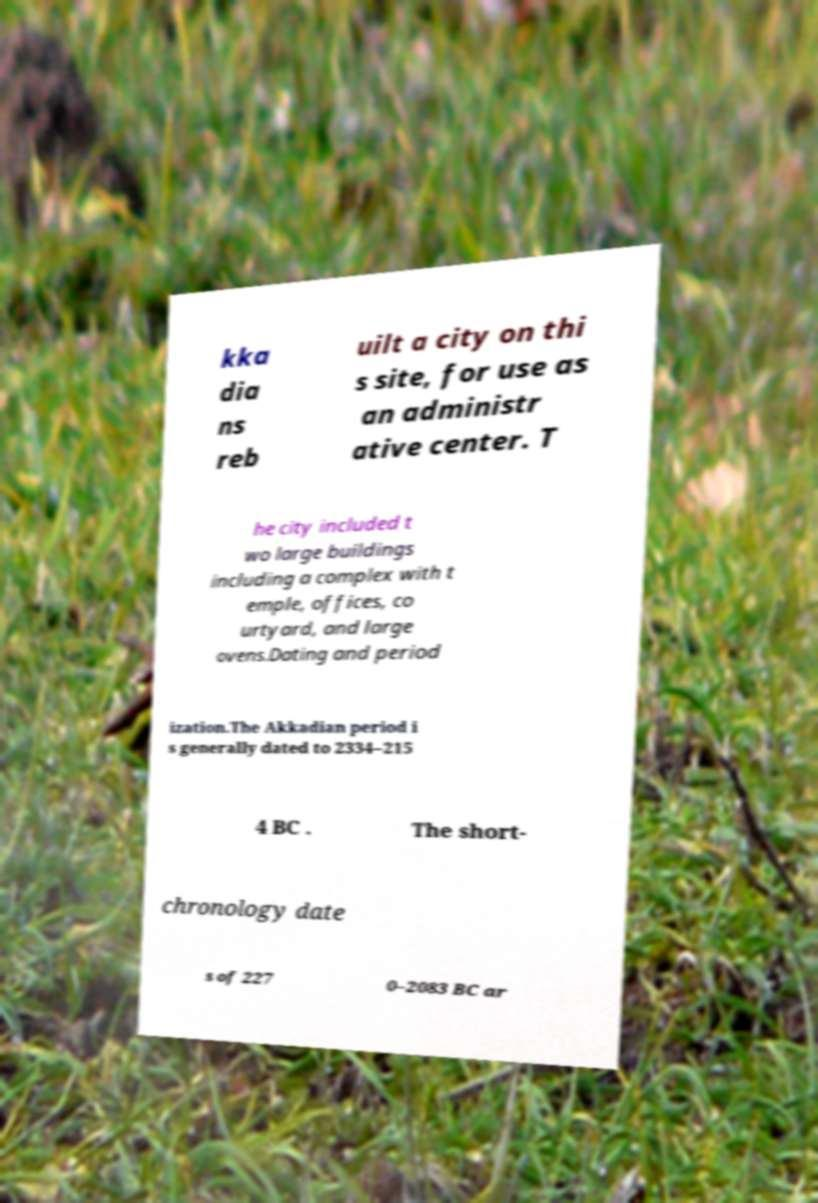What messages or text are displayed in this image? I need them in a readable, typed format. kka dia ns reb uilt a city on thi s site, for use as an administr ative center. T he city included t wo large buildings including a complex with t emple, offices, co urtyard, and large ovens.Dating and period ization.The Akkadian period i s generally dated to 2334–215 4 BC . The short- chronology date s of 227 0–2083 BC ar 